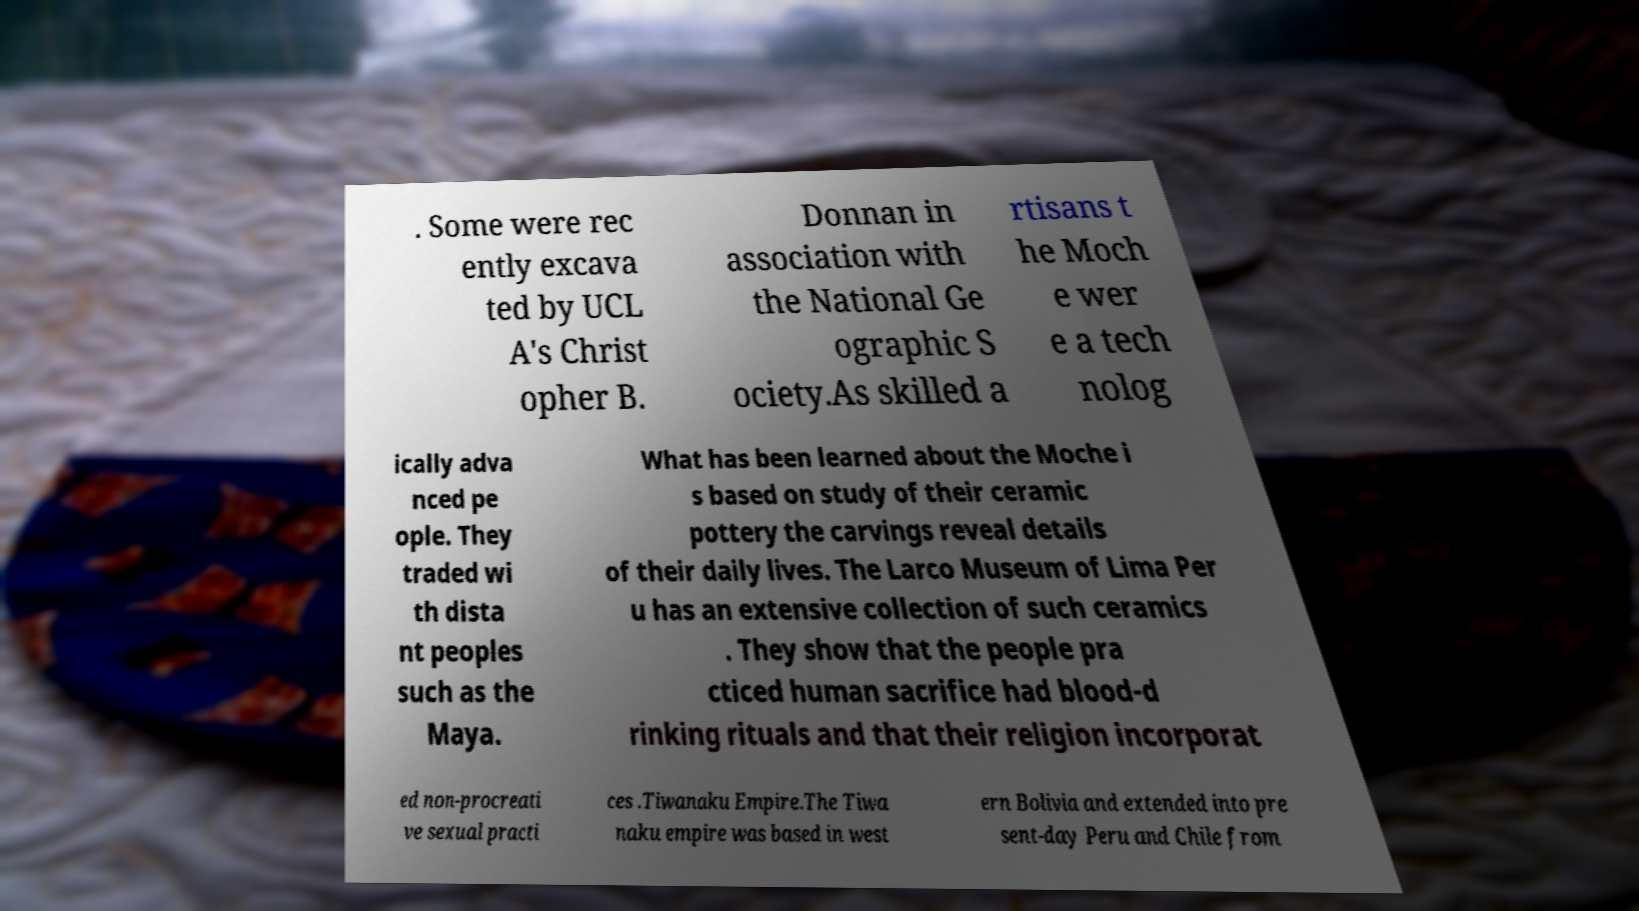Please identify and transcribe the text found in this image. . Some were rec ently excava ted by UCL A's Christ opher B. Donnan in association with the National Ge ographic S ociety.As skilled a rtisans t he Moch e wer e a tech nolog ically adva nced pe ople. They traded wi th dista nt peoples such as the Maya. What has been learned about the Moche i s based on study of their ceramic pottery the carvings reveal details of their daily lives. The Larco Museum of Lima Per u has an extensive collection of such ceramics . They show that the people pra cticed human sacrifice had blood-d rinking rituals and that their religion incorporat ed non-procreati ve sexual practi ces .Tiwanaku Empire.The Tiwa naku empire was based in west ern Bolivia and extended into pre sent-day Peru and Chile from 